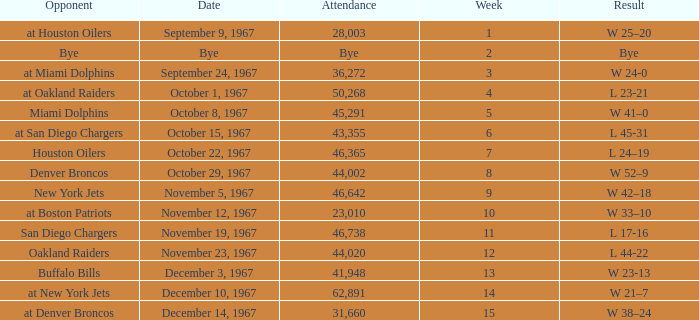What week did the September 9, 1967 game occur on? 1.0. 